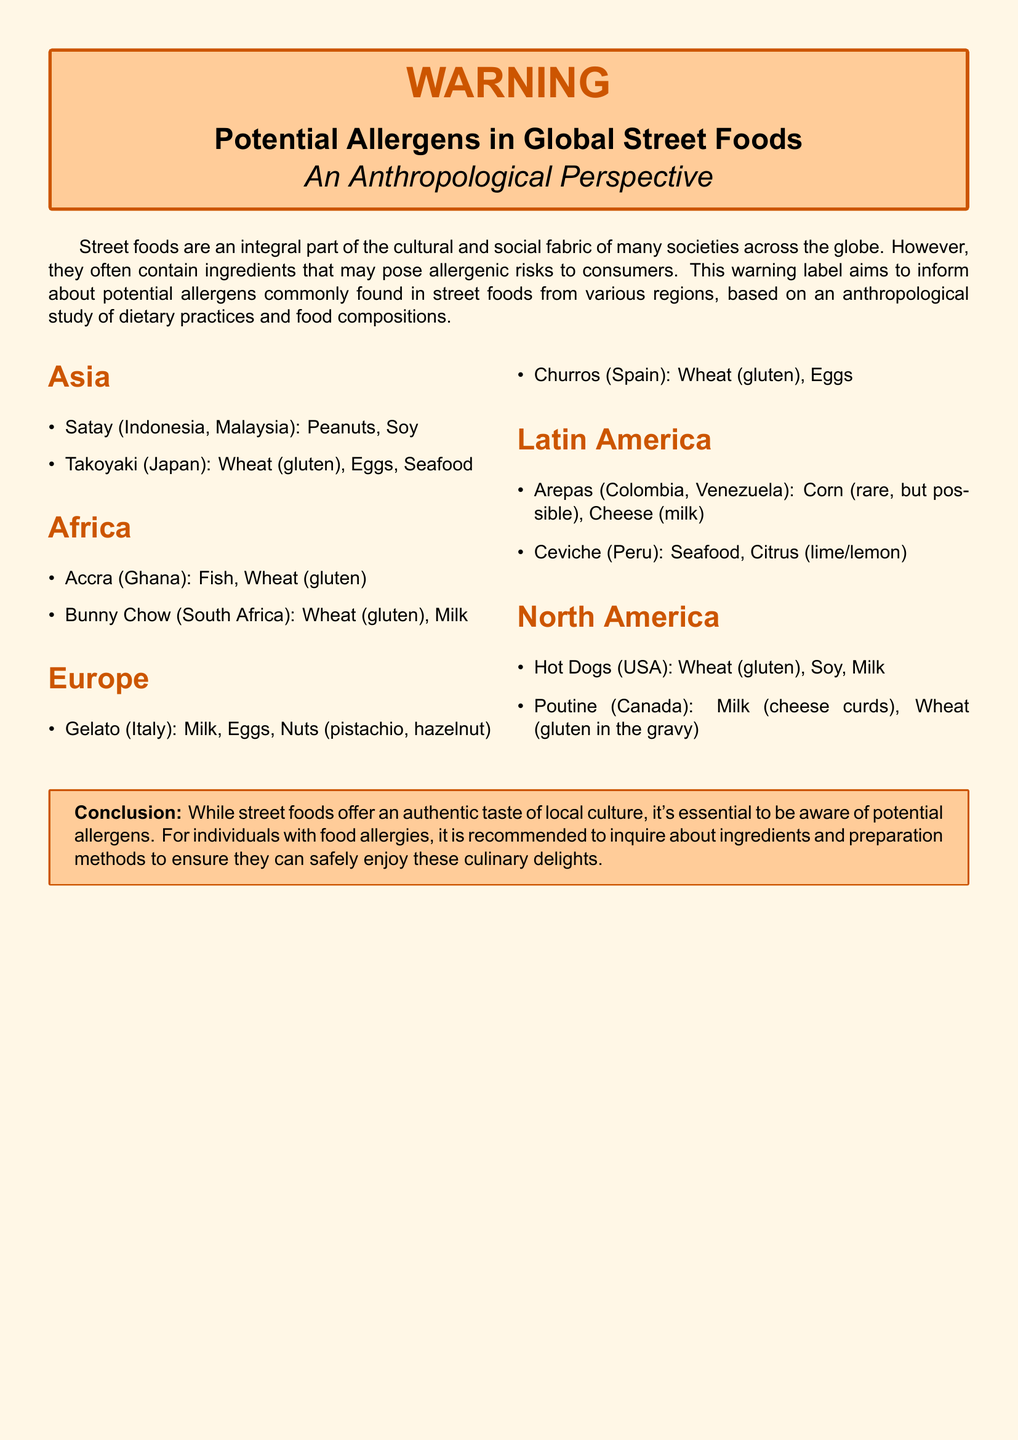What allergens are in Satay? Satay contains peanuts and soy as potential allergens.
Answer: Peanuts, Soy What is a common allergen in Takoyaki? Takoyaki commonly contains wheat (gluten), which is a potential allergen.
Answer: Wheat (gluten) What type of allergen is found in Ceviche? Ceviche includes seafood as a potential allergen.
Answer: Seafood Which country is known for Bunny Chow? Bunny Chow is a dish from South Africa.
Answer: South Africa How many allergens are mentioned for Gelato? Gelato has three potential allergens listed in the document.
Answer: Three Which continent has street foods that include cheese as a potential allergen? The document states that cheese is a potential allergen in Arepas from Latin America.
Answer: Latin America What conclusion does the warning label provide about street foods? The conclusion emphasizes the necessity of being aware of potential allergens in street foods.
Answer: Awareness of potential allergens What type of document is this? The document serves as a warning label about potential allergens in global street foods.
Answer: Warning label 